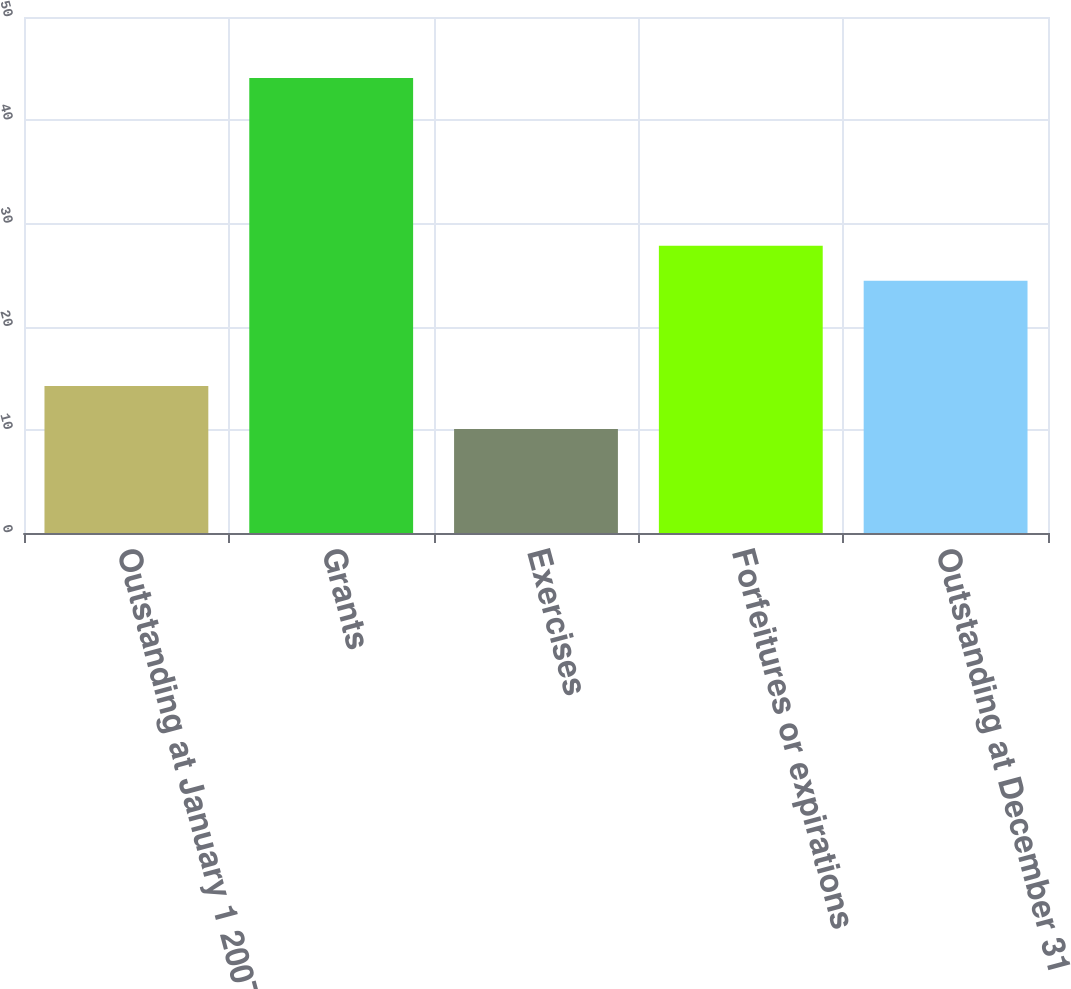Convert chart to OTSL. <chart><loc_0><loc_0><loc_500><loc_500><bar_chart><fcel>Outstanding at January 1 2007<fcel>Grants<fcel>Exercises<fcel>Forfeitures or expirations<fcel>Outstanding at December 31<nl><fcel>14.24<fcel>44.09<fcel>10.08<fcel>27.84<fcel>24.44<nl></chart> 